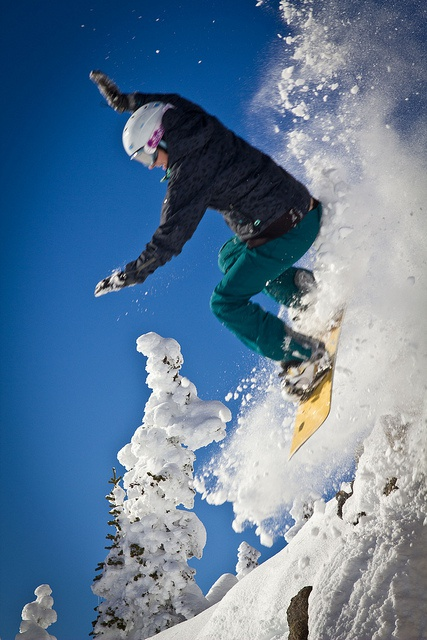Describe the objects in this image and their specific colors. I can see people in navy, black, darkblue, gray, and darkgray tones and snowboard in navy, tan, lightgray, darkgray, and khaki tones in this image. 